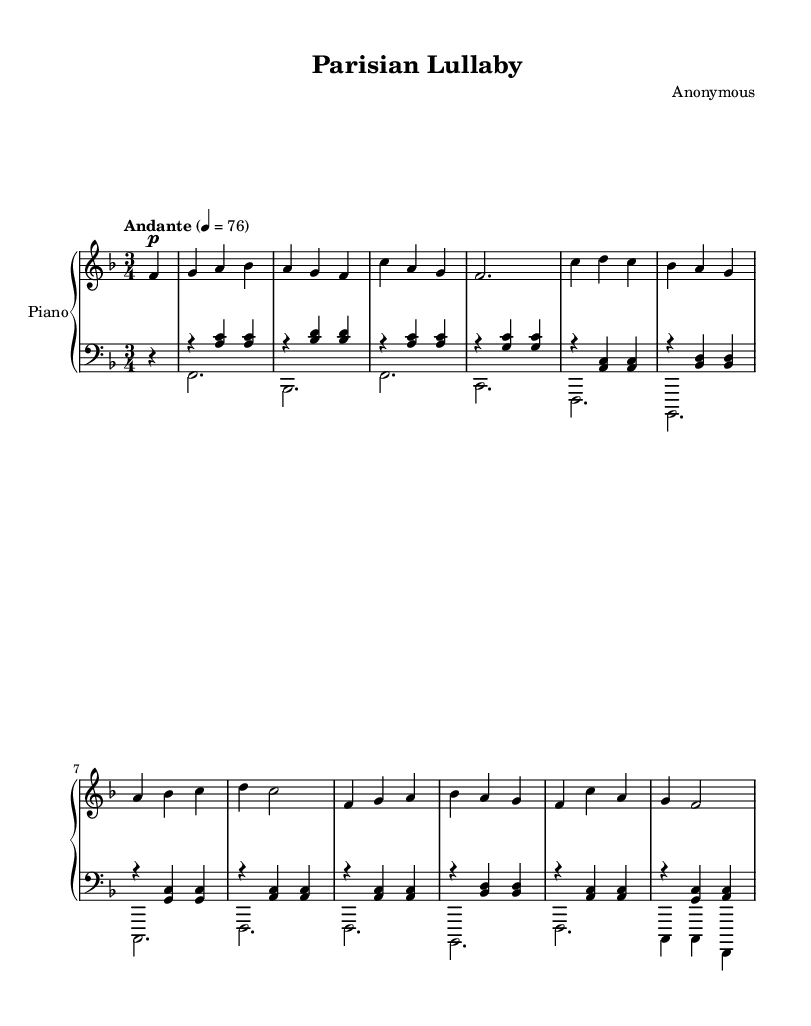What is the key signature of this music? The key signature is F major, which has one flat (B flat). This can be determined by looking at the key signature section in the music notation, where there is a flat on the B line.
Answer: F major What is the time signature of this music? The time signature is 3/4, indicated at the beginning of the score. This means there are three beats per measure, and each beat is a quarter note.
Answer: 3/4 What is the tempo marking for this piece? The tempo marking is Andante, which signifies a moderate walking pace. It is marked at the beginning of the score along with the metronome setting of 76 beats per minute.
Answer: Andante How many measures are there in the right hand part? The right hand part consists of 8 measures, which can be counted by identifying the vertical lines that separate the measures in the notated music.
Answer: 8 What is the form of this sonata? The form of this sonata is ternary (ABA), which can be deduced from the structure of the sections presented in the music. The piece first presents a theme (A), then contrasts with a different section (B), and returns to the original theme (A) at the end.
Answer: Ternary Which dynamic marking is used in the first measure? The dynamic marking in the first measure is piano (p), which instructs the player to play softly. This marking is located below the first note.
Answer: piano What is the highest note played in this piece? The highest note played in this piece is C', appearing in the right hand's melody. This can be confirmed by scanning through the right-hand notes to identify their ranges.
Answer: C' 